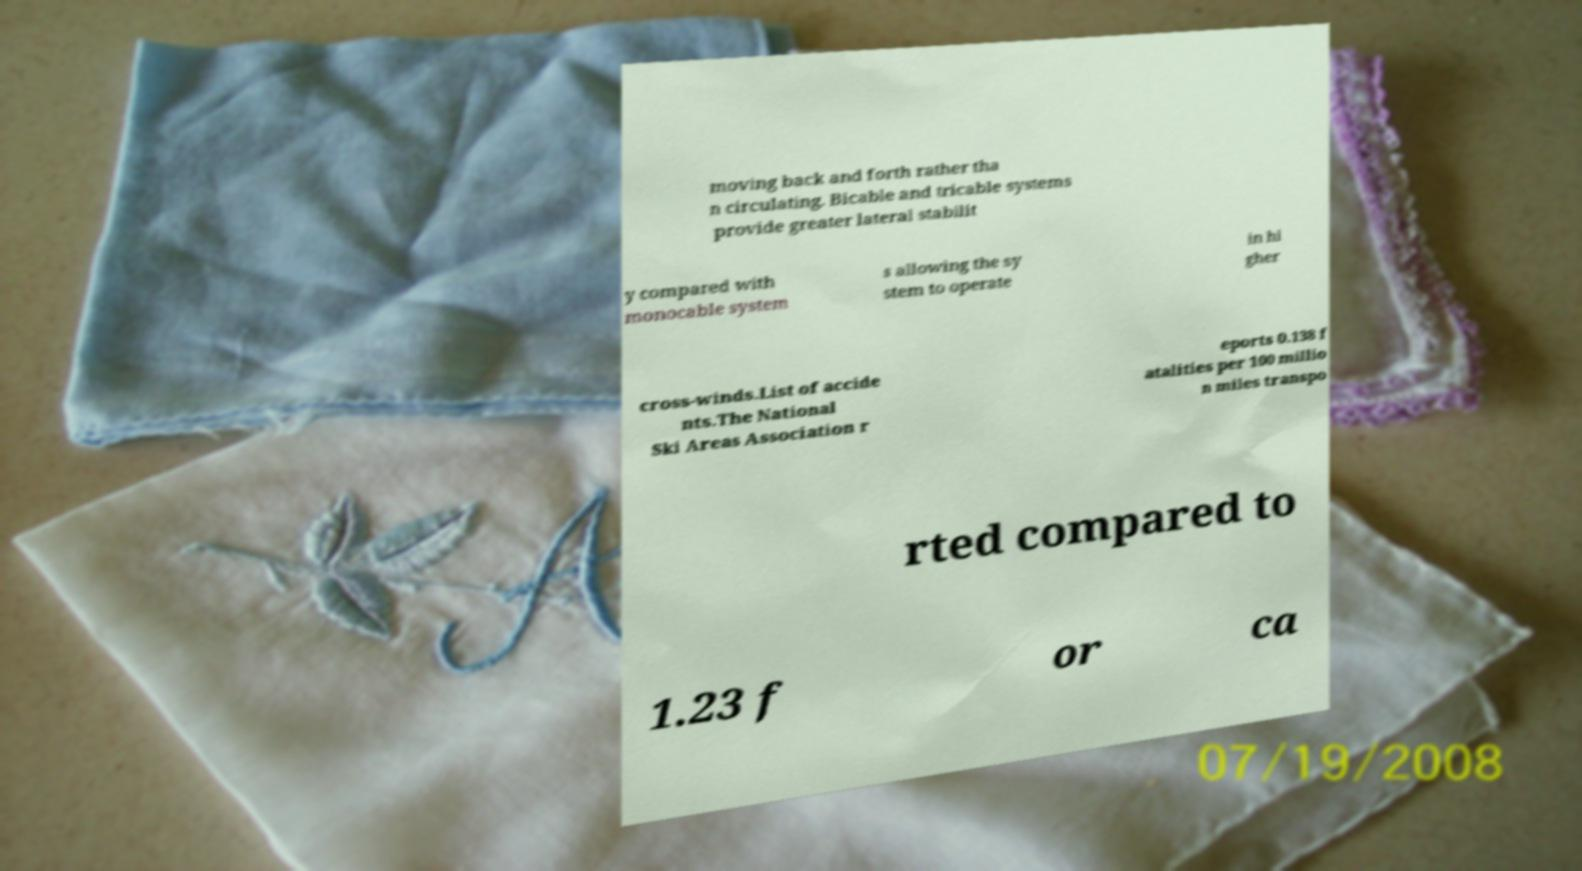Could you assist in decoding the text presented in this image and type it out clearly? moving back and forth rather tha n circulating. Bicable and tricable systems provide greater lateral stabilit y compared with monocable system s allowing the sy stem to operate in hi gher cross-winds.List of accide nts.The National Ski Areas Association r eports 0.138 f atalities per 100 millio n miles transpo rted compared to 1.23 f or ca 